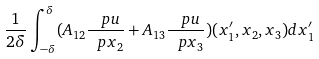Convert formula to latex. <formula><loc_0><loc_0><loc_500><loc_500>\frac { 1 } { 2 \delta } \int _ { - \delta } ^ { \delta } ( A _ { 1 2 } \frac { \ p u } { \ p x _ { 2 } } + A _ { 1 3 } \frac { \ p u } { \ p x _ { 3 } } ) ( x ^ { \prime } _ { 1 } , x _ { 2 } , x _ { 3 } ) d x ^ { \prime } _ { 1 }</formula> 